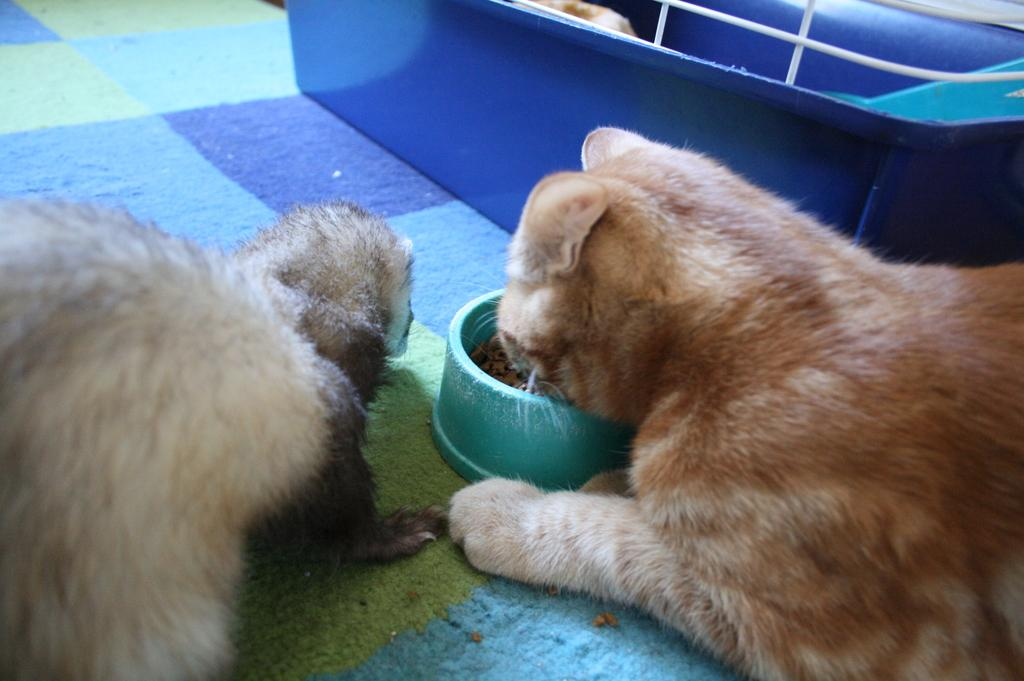What animals are on the floor in the image? There are cats on the floor in the image. What can be seen in the background of the image? There is a tub in the background of the image. What type of card is being used by the cats to join the cart in the image? There is no card or cart present in the image; it only features cats on the floor and a tub in the background. 